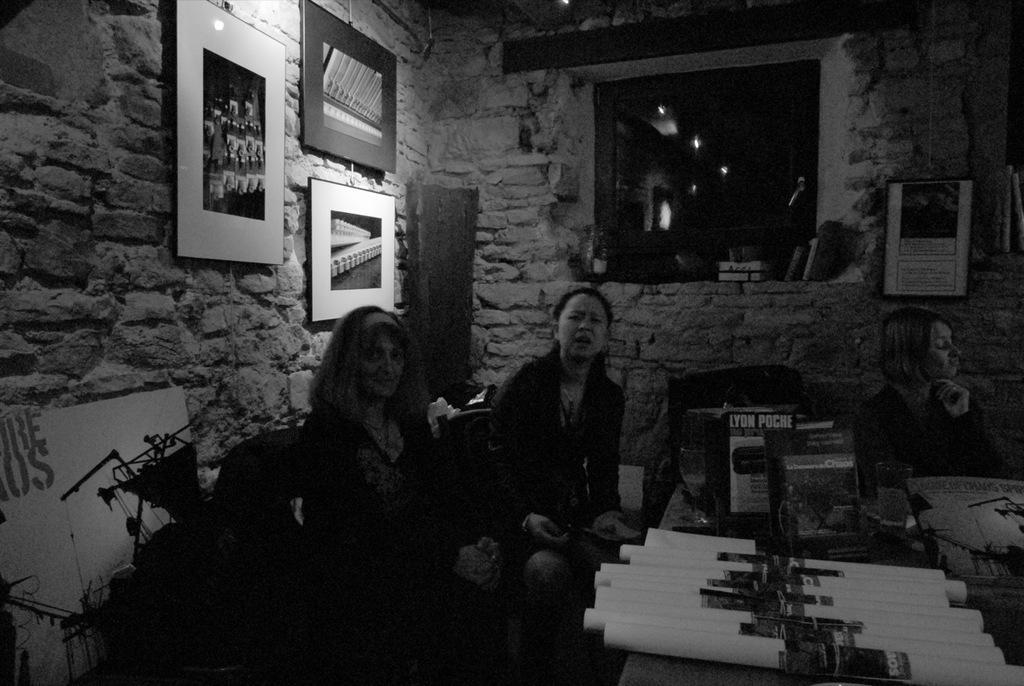Can you describe this image briefly? This is black and white picture,there are three women sitting and we can see glass and objects on the table. In the background we can see frames on the wall and window and we can see objects on shelf. 